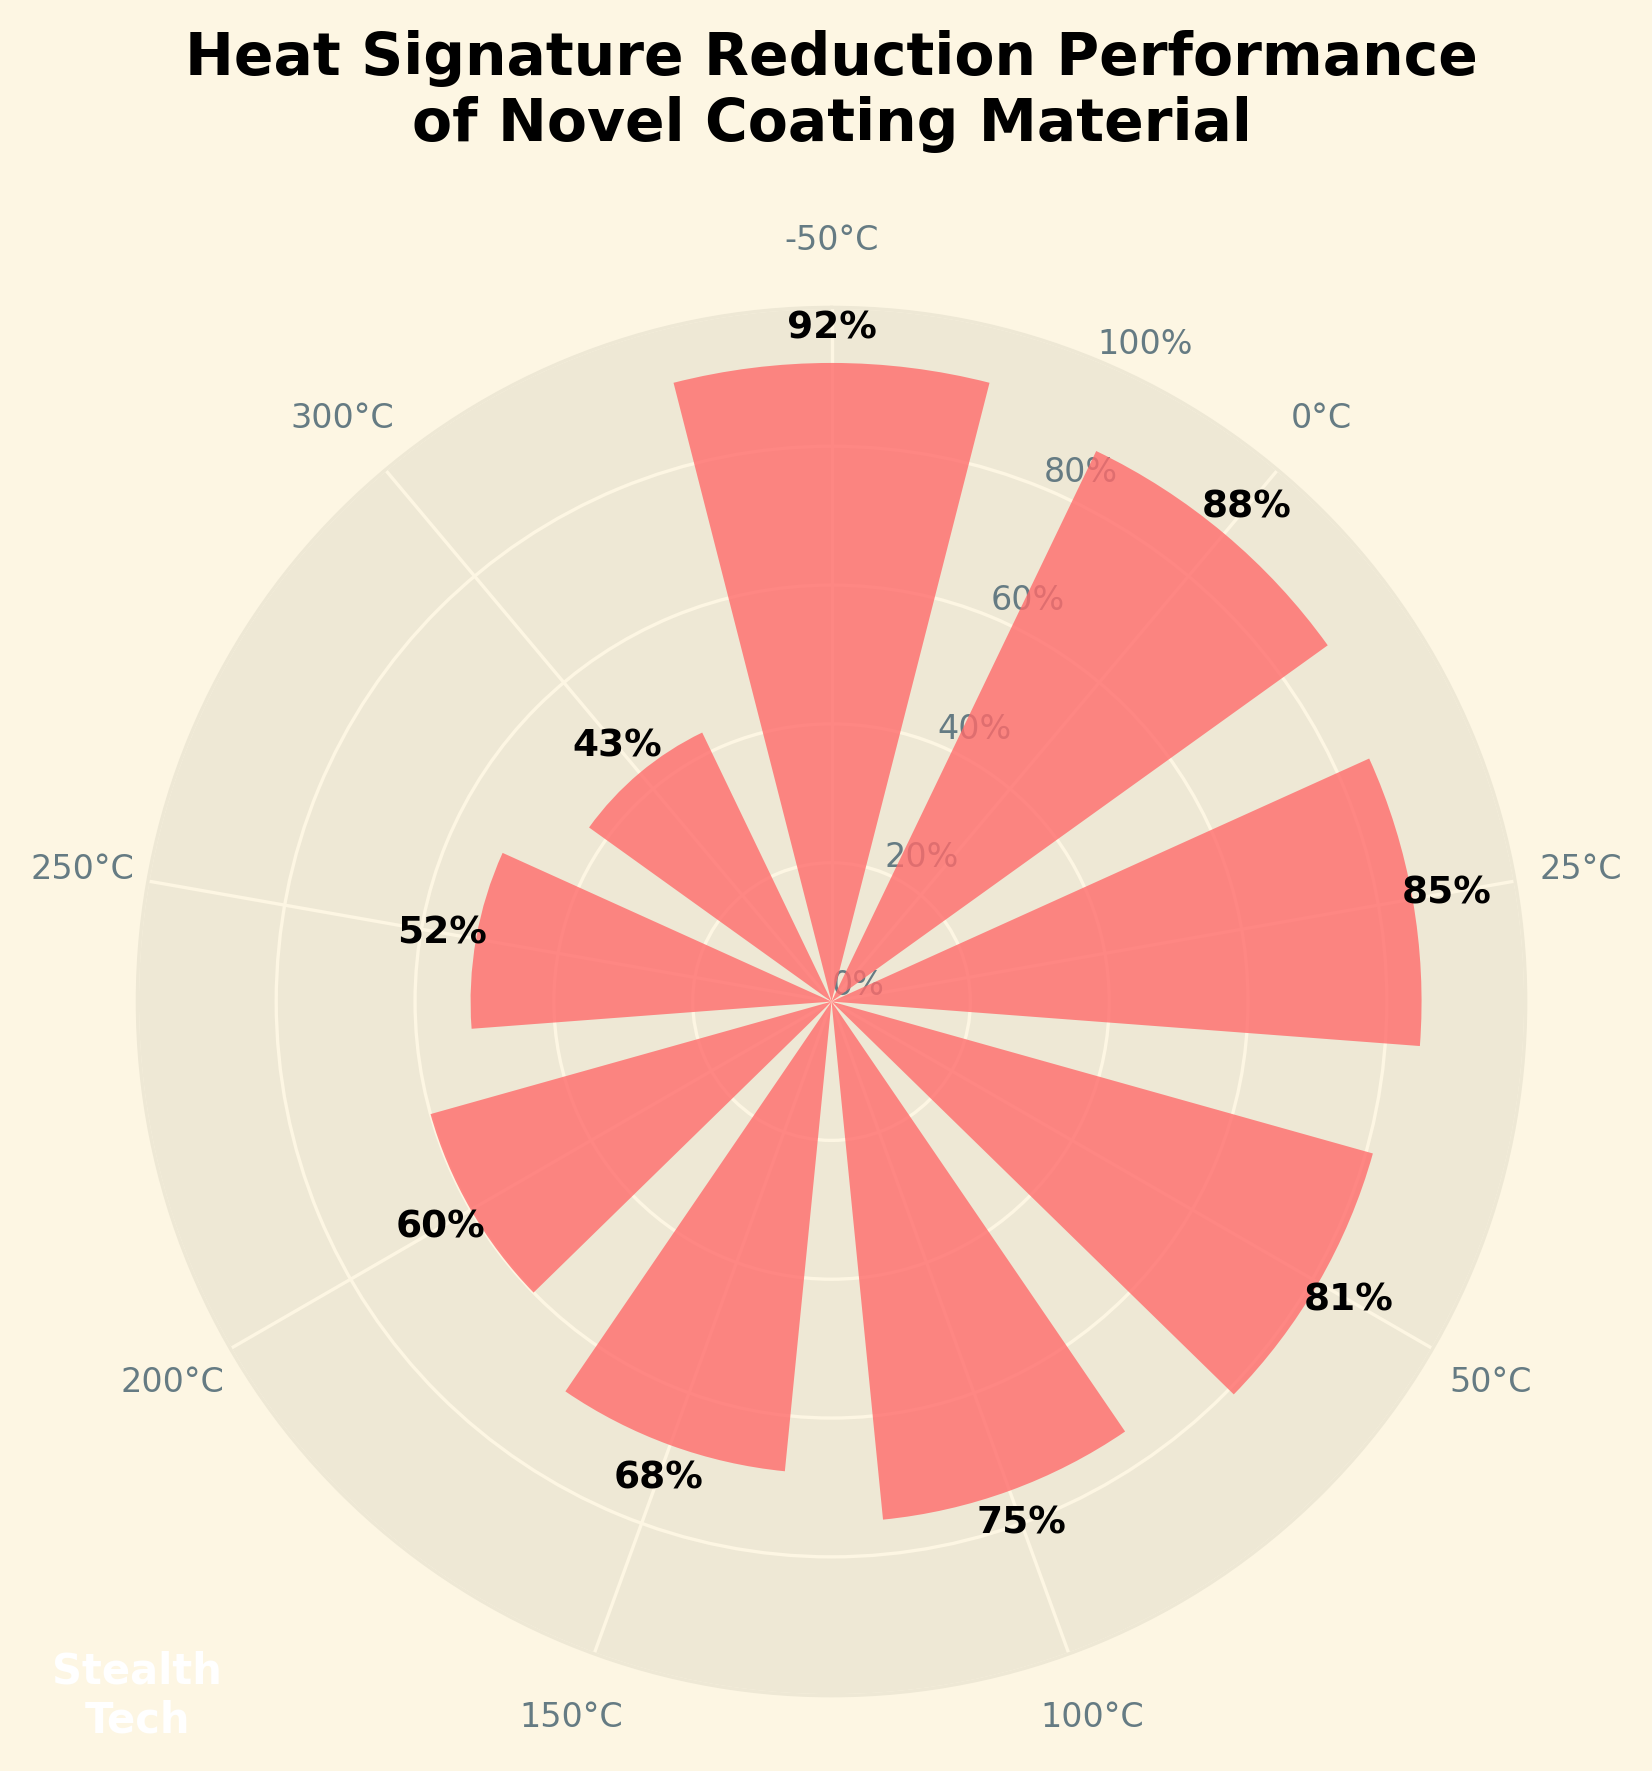What is the title of the figure? The title of the figure appears at the top of the plot and provides a summary of what the figure represents. In this case, it states: "Heat Signature Reduction Performance of Novel Coating Material".
Answer: Heat Signature Reduction Performance of Novel Coating Material How many temperatures are shown in the figure? There are multiple bars evenly spaced around the circular figure. Each bar represents a different temperature, with labels ranging from -50 to 300°C. Counting these labels gives us the total number of temperatures.
Answer: 9 What is the heat signature reduction at 100°C? Locate the bar labeled 100°C on the perimeter of the figure. The height of the bar corresponds to the heat signature reduction percentage, which is labeled near the top of the bar.
Answer: 75% At what temperature is the heat signature reduction the lowest? To determine the lowest heat signature reduction, look for the shortest bar among all the bars. The label of this bar indicates the corresponding temperature, which in this case is 300°C.
Answer: 300°C What is the difference in heat signature reduction between 0°C and 50°C? Find the heat signature reductions for both 0°C and 50°C. The former reduction is 88% and the latter is 81%. Calculating the difference: 88% - 81% = 7%.
Answer: 7% Which temperature shows a higher heat signature reduction: 150°C or 200°C? Compare the bars for 150°C and 200°C. The heat signature reduction at 150°C is 68% while at 200°C it is 60%. Since 68% is higher than 60%, 150°C has the higher reduction.
Answer: 150°C What percentage range is covered by the y-ticks? The y-ticks are labeled in intervals of 20%, starting from 0% up to 100%. This covers a range of 0% to 100%.
Answer: 0% to 100% What is the average heat signature reduction across all temperatures shown? To find the average reduction, add up the given reductions and divide by the number of data points. Summing the reductions: 92% + 88% + 85% + 81% + 75% + 68% + 60% + 52% + 43% = 644%. Dividing by 9 temperatures: 644% / 9 = 71.56%.
Answer: 71.56% What is the visual appearance of the central circle in the figure? The central circle has a background color and text inside it. The circle is greenish with text "Stealth Tech" in white and is positioned in the center of the plot.
Answer: Greenish circle with "Stealth Tech" text 